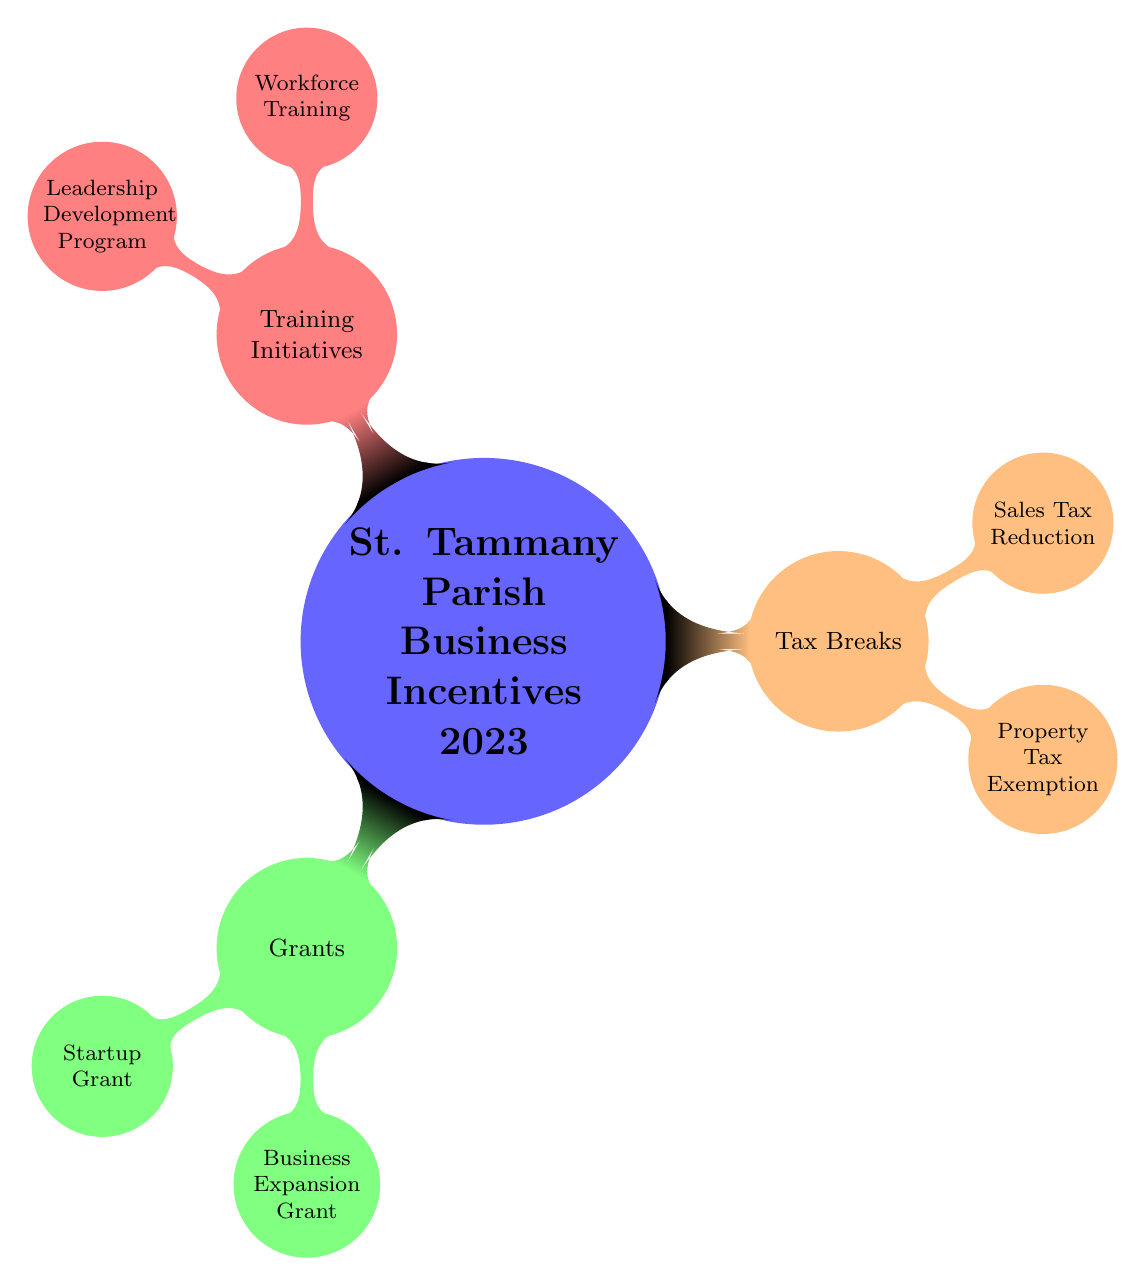What are the main categories of business incentives in St. Tammany Parish for 2023? The diagram outlines three main categories of business incentives in St. Tammany Parish for 2023: Grants, Tax Breaks, and Training Initiatives.
Answer: Grants, Tax Breaks, Training Initiatives How many types of grants are listed in the diagram? The diagram indicates two types of grants: Startup Grant and Business Expansion Grant. Therefore, counting these, we have a total of 2 types of grants.
Answer: 2 What is one type of tax break mentioned in the diagram? The diagram includes two tax breaks: Property Tax Exemption and Sales Tax Reduction. One example from these is the Property Tax Exemption.
Answer: Property Tax Exemption Which training initiative focuses on developing leadership skills? The diagram specifies a training initiative known as the Leadership Development Program, which is designed to enhance leadership skills.
Answer: Leadership Development Program What is the relationship between Grants and Training Initiatives in the diagram? The diagram presents Grants and Training Initiatives as two distinct categories under the broader overview of business incentives. They are branches stemming from the main node titled "St. Tammany Parish Business Incentives 2023," indicating that both are part of the same overarching theme of supporting businesses.
Answer: Distinct categories How many total nodes are there in the diagram? Counting all the nodes, we have one main node (St. Tammany Parish Business Incentives 2023), three branch nodes (Grants, Tax Breaks, Training Initiatives), and a total of four child nodes under these categories: two under Grants, two under Tax Breaks, and two under Training Initiatives. In total, this sums up to 1 + 3 + 6 = 10 nodes.
Answer: 10 Which category includes the Workforce Training initiative? In the diagram, Workforce Training falls under the Training Initiatives category. This shows that the initiative is focused on developing the skills of the workforce.
Answer: Training Initiatives What is the total number of subcategories under Tax Breaks? The diagram indicates there are two subcategories listed under Tax Breaks: Property Tax Exemption and Sales Tax Reduction. Counting these, we find there are 2 subcategories.
Answer: 2 Which category does the Business Expansion Grant belong to? The Business Expansion Grant is identified within the Grants category as one of the specific types of grants available under the business incentive programs.
Answer: Grants 